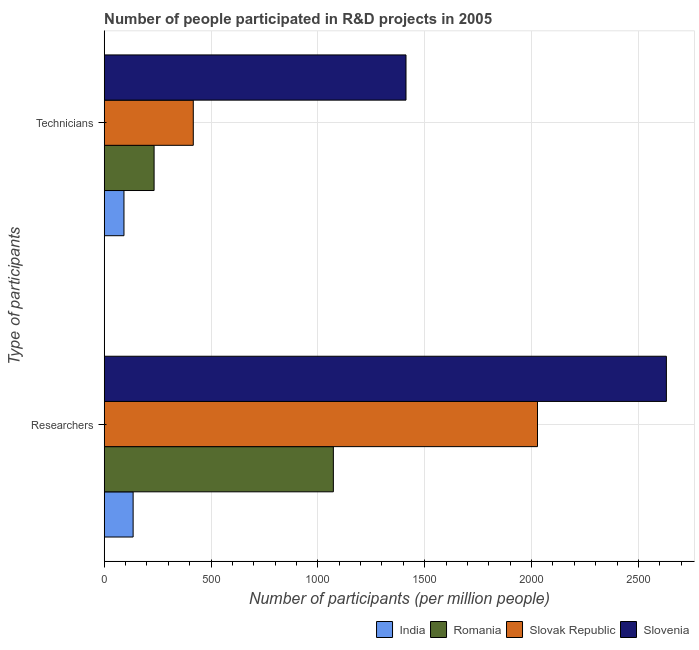How many groups of bars are there?
Keep it short and to the point. 2. Are the number of bars per tick equal to the number of legend labels?
Give a very brief answer. Yes. Are the number of bars on each tick of the Y-axis equal?
Provide a short and direct response. Yes. How many bars are there on the 2nd tick from the bottom?
Provide a short and direct response. 4. What is the label of the 2nd group of bars from the top?
Your response must be concise. Researchers. What is the number of researchers in India?
Offer a terse response. 135.3. Across all countries, what is the maximum number of technicians?
Your response must be concise. 1412.46. Across all countries, what is the minimum number of researchers?
Make the answer very short. 135.3. In which country was the number of researchers maximum?
Keep it short and to the point. Slovenia. What is the total number of technicians in the graph?
Keep it short and to the point. 2155.23. What is the difference between the number of researchers in India and that in Romania?
Your response must be concise. -937.12. What is the difference between the number of technicians in Romania and the number of researchers in India?
Offer a terse response. 98.17. What is the average number of researchers per country?
Offer a terse response. 1466.67. What is the difference between the number of researchers and number of technicians in India?
Your response must be concise. 42.84. What is the ratio of the number of technicians in India to that in Slovenia?
Provide a short and direct response. 0.07. In how many countries, is the number of researchers greater than the average number of researchers taken over all countries?
Give a very brief answer. 2. What does the 1st bar from the top in Researchers represents?
Provide a short and direct response. Slovenia. What does the 3rd bar from the bottom in Technicians represents?
Your answer should be compact. Slovak Republic. Are all the bars in the graph horizontal?
Give a very brief answer. Yes. How many countries are there in the graph?
Your answer should be compact. 4. What is the difference between two consecutive major ticks on the X-axis?
Give a very brief answer. 500. Where does the legend appear in the graph?
Provide a short and direct response. Bottom right. What is the title of the graph?
Make the answer very short. Number of people participated in R&D projects in 2005. What is the label or title of the X-axis?
Your answer should be compact. Number of participants (per million people). What is the label or title of the Y-axis?
Offer a very short reply. Type of participants. What is the Number of participants (per million people) in India in Researchers?
Provide a succinct answer. 135.3. What is the Number of participants (per million people) in Romania in Researchers?
Your answer should be very brief. 1072.42. What is the Number of participants (per million people) of Slovak Republic in Researchers?
Your response must be concise. 2027.89. What is the Number of participants (per million people) of Slovenia in Researchers?
Provide a short and direct response. 2631.08. What is the Number of participants (per million people) of India in Technicians?
Give a very brief answer. 92.46. What is the Number of participants (per million people) in Romania in Technicians?
Provide a short and direct response. 233.47. What is the Number of participants (per million people) of Slovak Republic in Technicians?
Ensure brevity in your answer.  416.85. What is the Number of participants (per million people) in Slovenia in Technicians?
Provide a succinct answer. 1412.46. Across all Type of participants, what is the maximum Number of participants (per million people) in India?
Provide a short and direct response. 135.3. Across all Type of participants, what is the maximum Number of participants (per million people) in Romania?
Make the answer very short. 1072.42. Across all Type of participants, what is the maximum Number of participants (per million people) of Slovak Republic?
Offer a very short reply. 2027.89. Across all Type of participants, what is the maximum Number of participants (per million people) of Slovenia?
Your answer should be very brief. 2631.08. Across all Type of participants, what is the minimum Number of participants (per million people) of India?
Keep it short and to the point. 92.46. Across all Type of participants, what is the minimum Number of participants (per million people) in Romania?
Make the answer very short. 233.47. Across all Type of participants, what is the minimum Number of participants (per million people) of Slovak Republic?
Offer a very short reply. 416.85. Across all Type of participants, what is the minimum Number of participants (per million people) of Slovenia?
Your answer should be compact. 1412.46. What is the total Number of participants (per million people) of India in the graph?
Provide a succinct answer. 227.76. What is the total Number of participants (per million people) in Romania in the graph?
Give a very brief answer. 1305.89. What is the total Number of participants (per million people) in Slovak Republic in the graph?
Ensure brevity in your answer.  2444.74. What is the total Number of participants (per million people) in Slovenia in the graph?
Give a very brief answer. 4043.53. What is the difference between the Number of participants (per million people) of India in Researchers and that in Technicians?
Provide a short and direct response. 42.84. What is the difference between the Number of participants (per million people) in Romania in Researchers and that in Technicians?
Give a very brief answer. 838.95. What is the difference between the Number of participants (per million people) in Slovak Republic in Researchers and that in Technicians?
Ensure brevity in your answer.  1611.05. What is the difference between the Number of participants (per million people) of Slovenia in Researchers and that in Technicians?
Offer a very short reply. 1218.62. What is the difference between the Number of participants (per million people) of India in Researchers and the Number of participants (per million people) of Romania in Technicians?
Give a very brief answer. -98.17. What is the difference between the Number of participants (per million people) of India in Researchers and the Number of participants (per million people) of Slovak Republic in Technicians?
Your answer should be compact. -281.55. What is the difference between the Number of participants (per million people) of India in Researchers and the Number of participants (per million people) of Slovenia in Technicians?
Your answer should be compact. -1277.16. What is the difference between the Number of participants (per million people) of Romania in Researchers and the Number of participants (per million people) of Slovak Republic in Technicians?
Your answer should be compact. 655.58. What is the difference between the Number of participants (per million people) of Romania in Researchers and the Number of participants (per million people) of Slovenia in Technicians?
Keep it short and to the point. -340.03. What is the difference between the Number of participants (per million people) of Slovak Republic in Researchers and the Number of participants (per million people) of Slovenia in Technicians?
Provide a short and direct response. 615.44. What is the average Number of participants (per million people) in India per Type of participants?
Give a very brief answer. 113.88. What is the average Number of participants (per million people) of Romania per Type of participants?
Your response must be concise. 652.95. What is the average Number of participants (per million people) in Slovak Republic per Type of participants?
Your response must be concise. 1222.37. What is the average Number of participants (per million people) of Slovenia per Type of participants?
Make the answer very short. 2021.77. What is the difference between the Number of participants (per million people) of India and Number of participants (per million people) of Romania in Researchers?
Give a very brief answer. -937.12. What is the difference between the Number of participants (per million people) of India and Number of participants (per million people) of Slovak Republic in Researchers?
Your answer should be very brief. -1892.59. What is the difference between the Number of participants (per million people) in India and Number of participants (per million people) in Slovenia in Researchers?
Your answer should be compact. -2495.78. What is the difference between the Number of participants (per million people) in Romania and Number of participants (per million people) in Slovak Republic in Researchers?
Keep it short and to the point. -955.47. What is the difference between the Number of participants (per million people) of Romania and Number of participants (per million people) of Slovenia in Researchers?
Offer a very short reply. -1558.65. What is the difference between the Number of participants (per million people) of Slovak Republic and Number of participants (per million people) of Slovenia in Researchers?
Ensure brevity in your answer.  -603.18. What is the difference between the Number of participants (per million people) in India and Number of participants (per million people) in Romania in Technicians?
Provide a succinct answer. -141.01. What is the difference between the Number of participants (per million people) of India and Number of participants (per million people) of Slovak Republic in Technicians?
Your answer should be compact. -324.38. What is the difference between the Number of participants (per million people) of India and Number of participants (per million people) of Slovenia in Technicians?
Your response must be concise. -1319.99. What is the difference between the Number of participants (per million people) of Romania and Number of participants (per million people) of Slovak Republic in Technicians?
Offer a terse response. -183.38. What is the difference between the Number of participants (per million people) of Romania and Number of participants (per million people) of Slovenia in Technicians?
Provide a succinct answer. -1178.99. What is the difference between the Number of participants (per million people) of Slovak Republic and Number of participants (per million people) of Slovenia in Technicians?
Ensure brevity in your answer.  -995.61. What is the ratio of the Number of participants (per million people) of India in Researchers to that in Technicians?
Ensure brevity in your answer.  1.46. What is the ratio of the Number of participants (per million people) of Romania in Researchers to that in Technicians?
Your response must be concise. 4.59. What is the ratio of the Number of participants (per million people) of Slovak Republic in Researchers to that in Technicians?
Your answer should be compact. 4.86. What is the ratio of the Number of participants (per million people) in Slovenia in Researchers to that in Technicians?
Your answer should be compact. 1.86. What is the difference between the highest and the second highest Number of participants (per million people) of India?
Offer a terse response. 42.84. What is the difference between the highest and the second highest Number of participants (per million people) of Romania?
Provide a succinct answer. 838.95. What is the difference between the highest and the second highest Number of participants (per million people) of Slovak Republic?
Your response must be concise. 1611.05. What is the difference between the highest and the second highest Number of participants (per million people) in Slovenia?
Your answer should be compact. 1218.62. What is the difference between the highest and the lowest Number of participants (per million people) in India?
Your answer should be compact. 42.84. What is the difference between the highest and the lowest Number of participants (per million people) in Romania?
Your response must be concise. 838.95. What is the difference between the highest and the lowest Number of participants (per million people) of Slovak Republic?
Your answer should be compact. 1611.05. What is the difference between the highest and the lowest Number of participants (per million people) of Slovenia?
Provide a succinct answer. 1218.62. 